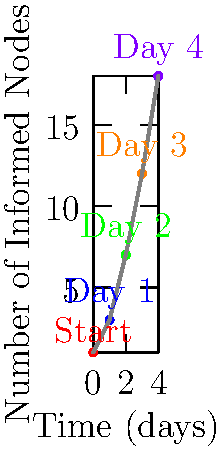As a journalist investigating the spread of a controversial government policy through social media, you come across this time-series graph showing the number of informed nodes (people) over time. What is the average daily increase in the number of informed nodes from Day 1 to Day 4? To find the average daily increase in informed nodes from Day 1 to Day 4:

1. Identify the number of informed nodes on Day 1 and Day 4:
   Day 1: 3 nodes
   Day 4: 18 nodes

2. Calculate the total increase in nodes:
   $18 - 3 = 15$ nodes

3. Determine the number of days between Day 1 and Day 4:
   $4 - 1 = 3$ days

4. Calculate the average daily increase:
   Average daily increase = Total increase ÷ Number of days
   $\frac{15}{3} = 5$ nodes per day

Therefore, the average daily increase in informed nodes from Day 1 to Day 4 is 5 nodes per day.
Answer: 5 nodes per day 